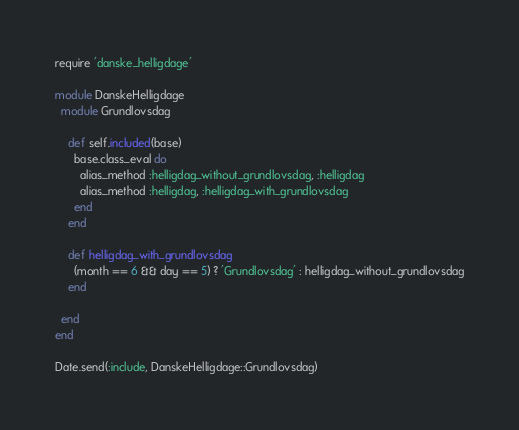<code> <loc_0><loc_0><loc_500><loc_500><_Ruby_>require 'danske_helligdage'

module DanskeHelligdage
  module Grundlovsdag

    def self.included(base)
      base.class_eval do
        alias_method :helligdag_without_grundlovsdag, :helligdag
        alias_method :helligdag, :helligdag_with_grundlovsdag
      end
    end

    def helligdag_with_grundlovsdag
      (month == 6 && day == 5) ? 'Grundlovsdag' : helligdag_without_grundlovsdag
    end

  end
end

Date.send(:include, DanskeHelligdage::Grundlovsdag)
</code> 